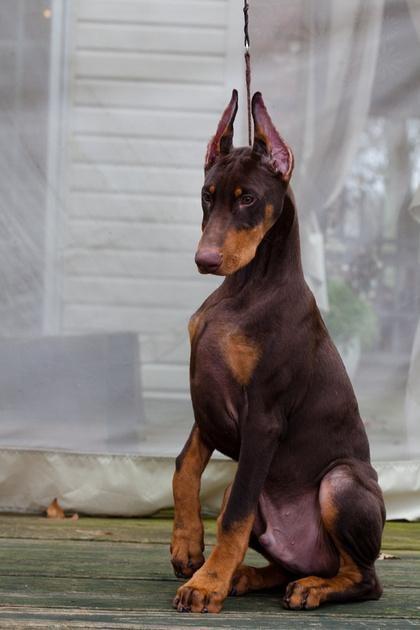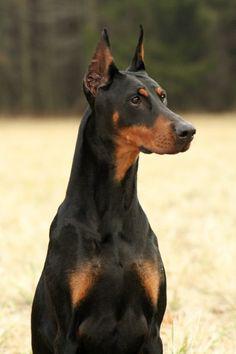The first image is the image on the left, the second image is the image on the right. Analyze the images presented: Is the assertion "Each image contains one erect-eared doberman posed outdoors, and one image shows a standing dog with front feet elevated and body turned rightward in front of autumn colors." valid? Answer yes or no. No. 